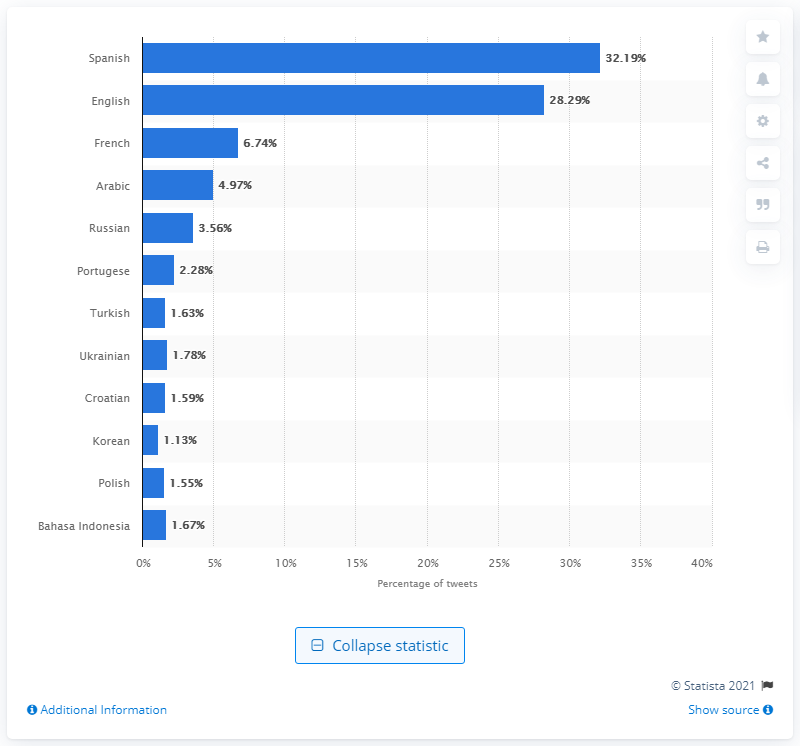Give some essential details in this illustration. According to data, only 32.19% of tweets from world leaders were in Spanish. 